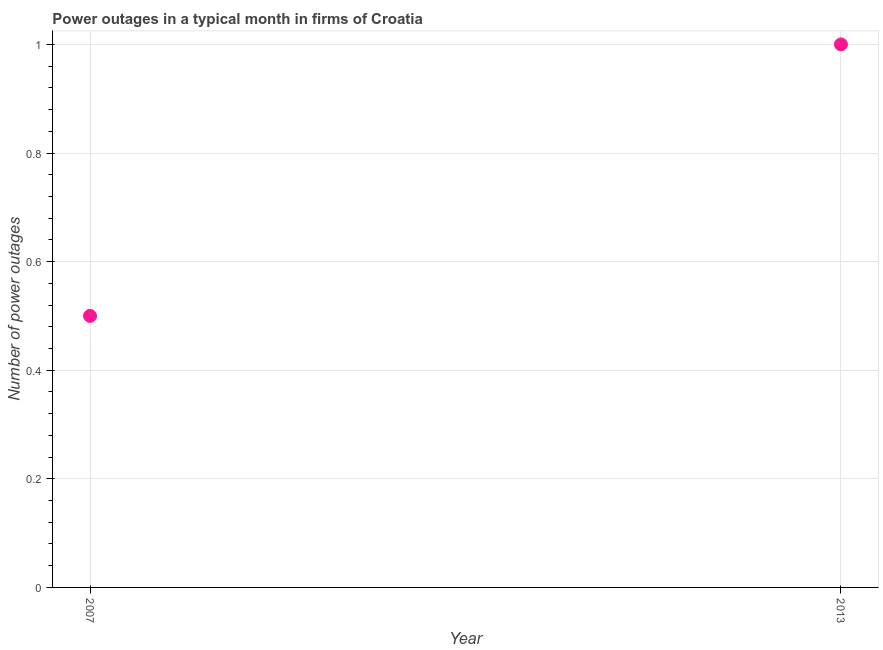In which year was the number of power outages maximum?
Your response must be concise. 2013. In which year was the number of power outages minimum?
Make the answer very short. 2007. In how many years, is the number of power outages greater than 0.32 ?
Provide a succinct answer. 2. In how many years, is the number of power outages greater than the average number of power outages taken over all years?
Offer a very short reply. 1. Does the number of power outages monotonically increase over the years?
Provide a succinct answer. Yes. How many dotlines are there?
Offer a very short reply. 1. How many years are there in the graph?
Give a very brief answer. 2. What is the difference between two consecutive major ticks on the Y-axis?
Provide a succinct answer. 0.2. Does the graph contain any zero values?
Keep it short and to the point. No. Does the graph contain grids?
Provide a succinct answer. Yes. What is the title of the graph?
Your answer should be compact. Power outages in a typical month in firms of Croatia. What is the label or title of the X-axis?
Make the answer very short. Year. What is the label or title of the Y-axis?
Make the answer very short. Number of power outages. What is the Number of power outages in 2007?
Offer a very short reply. 0.5. 